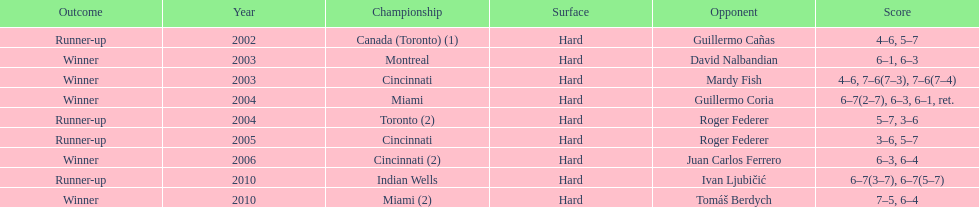What was the greatest number of sequential triumphs? 3. I'm looking to parse the entire table for insights. Could you assist me with that? {'header': ['Outcome', 'Year', 'Championship', 'Surface', 'Opponent', 'Score'], 'rows': [['Runner-up', '2002', 'Canada (Toronto) (1)', 'Hard', 'Guillermo Cañas', '4–6, 5–7'], ['Winner', '2003', 'Montreal', 'Hard', 'David Nalbandian', '6–1, 6–3'], ['Winner', '2003', 'Cincinnati', 'Hard', 'Mardy Fish', '4–6, 7–6(7–3), 7–6(7–4)'], ['Winner', '2004', 'Miami', 'Hard', 'Guillermo Coria', '6–7(2–7), 6–3, 6–1, ret.'], ['Runner-up', '2004', 'Toronto (2)', 'Hard', 'Roger Federer', '5–7, 3–6'], ['Runner-up', '2005', 'Cincinnati', 'Hard', 'Roger Federer', '3–6, 5–7'], ['Winner', '2006', 'Cincinnati (2)', 'Hard', 'Juan Carlos Ferrero', '6–3, 6–4'], ['Runner-up', '2010', 'Indian Wells', 'Hard', 'Ivan Ljubičić', '6–7(3–7), 6–7(5–7)'], ['Winner', '2010', 'Miami (2)', 'Hard', 'Tomáš Berdych', '7–5, 6–4']]} 